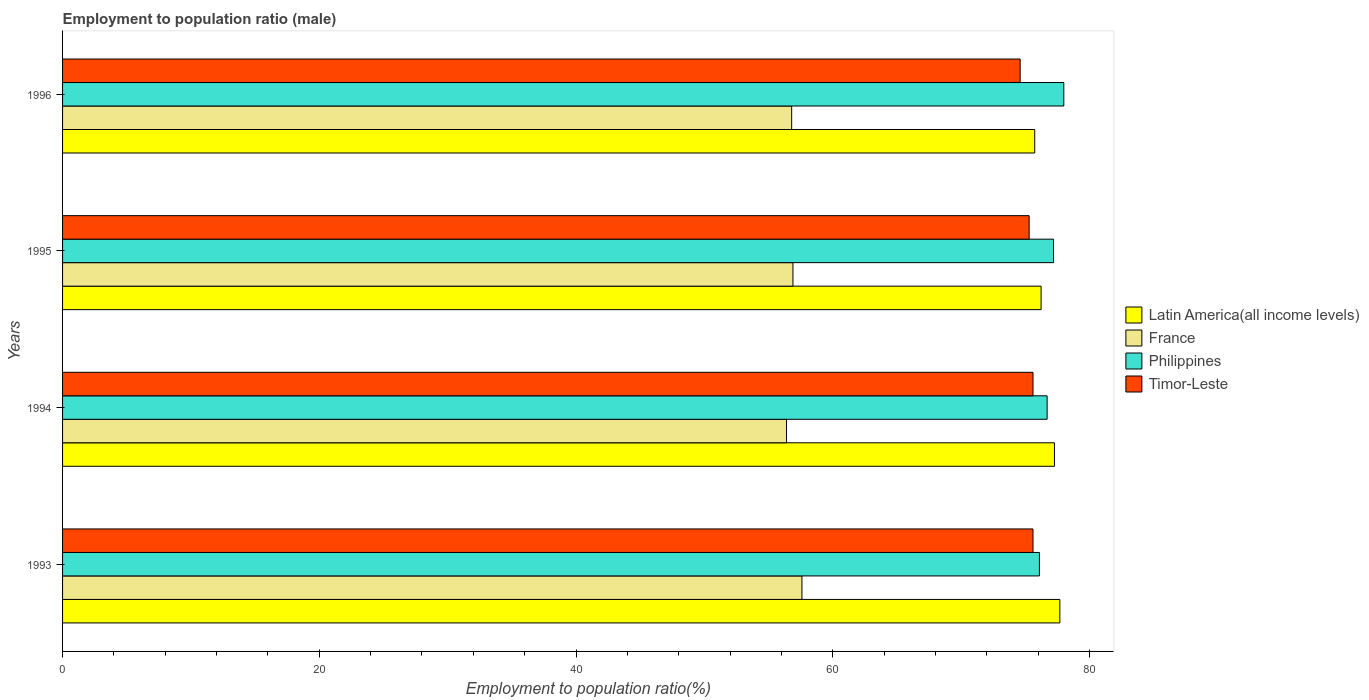How many different coloured bars are there?
Ensure brevity in your answer.  4. How many bars are there on the 3rd tick from the top?
Give a very brief answer. 4. How many bars are there on the 4th tick from the bottom?
Your answer should be compact. 4. In how many cases, is the number of bars for a given year not equal to the number of legend labels?
Provide a succinct answer. 0. What is the employment to population ratio in Timor-Leste in 1993?
Ensure brevity in your answer.  75.6. Across all years, what is the maximum employment to population ratio in Latin America(all income levels)?
Your answer should be compact. 77.69. Across all years, what is the minimum employment to population ratio in Timor-Leste?
Offer a terse response. 74.6. In which year was the employment to population ratio in France maximum?
Your answer should be very brief. 1993. In which year was the employment to population ratio in Philippines minimum?
Offer a very short reply. 1993. What is the total employment to population ratio in Philippines in the graph?
Your answer should be very brief. 308. What is the difference between the employment to population ratio in Philippines in 1995 and that in 1996?
Keep it short and to the point. -0.8. What is the difference between the employment to population ratio in France in 1993 and the employment to population ratio in Latin America(all income levels) in 1996?
Give a very brief answer. -18.13. What is the average employment to population ratio in Philippines per year?
Offer a terse response. 77. In the year 1996, what is the difference between the employment to population ratio in Timor-Leste and employment to population ratio in Latin America(all income levels)?
Offer a very short reply. -1.13. What is the ratio of the employment to population ratio in France in 1995 to that in 1996?
Give a very brief answer. 1. Is the difference between the employment to population ratio in Timor-Leste in 1994 and 1996 greater than the difference between the employment to population ratio in Latin America(all income levels) in 1994 and 1996?
Make the answer very short. No. What is the difference between the highest and the second highest employment to population ratio in Philippines?
Ensure brevity in your answer.  0.8. What is the difference between the highest and the lowest employment to population ratio in France?
Offer a terse response. 1.2. Is it the case that in every year, the sum of the employment to population ratio in France and employment to population ratio in Latin America(all income levels) is greater than the sum of employment to population ratio in Philippines and employment to population ratio in Timor-Leste?
Make the answer very short. No. What does the 3rd bar from the top in 1995 represents?
Your response must be concise. France. What does the 1st bar from the bottom in 1994 represents?
Offer a terse response. Latin America(all income levels). Is it the case that in every year, the sum of the employment to population ratio in France and employment to population ratio in Latin America(all income levels) is greater than the employment to population ratio in Philippines?
Your answer should be compact. Yes. How many bars are there?
Your response must be concise. 16. Are all the bars in the graph horizontal?
Your answer should be compact. Yes. How many years are there in the graph?
Ensure brevity in your answer.  4. Are the values on the major ticks of X-axis written in scientific E-notation?
Offer a very short reply. No. Where does the legend appear in the graph?
Your answer should be very brief. Center right. What is the title of the graph?
Offer a very short reply. Employment to population ratio (male). What is the label or title of the X-axis?
Offer a very short reply. Employment to population ratio(%). What is the Employment to population ratio(%) of Latin America(all income levels) in 1993?
Offer a terse response. 77.69. What is the Employment to population ratio(%) of France in 1993?
Keep it short and to the point. 57.6. What is the Employment to population ratio(%) in Philippines in 1993?
Keep it short and to the point. 76.1. What is the Employment to population ratio(%) of Timor-Leste in 1993?
Provide a short and direct response. 75.6. What is the Employment to population ratio(%) of Latin America(all income levels) in 1994?
Make the answer very short. 77.27. What is the Employment to population ratio(%) in France in 1994?
Your answer should be very brief. 56.4. What is the Employment to population ratio(%) of Philippines in 1994?
Keep it short and to the point. 76.7. What is the Employment to population ratio(%) in Timor-Leste in 1994?
Provide a short and direct response. 75.6. What is the Employment to population ratio(%) of Latin America(all income levels) in 1995?
Give a very brief answer. 76.23. What is the Employment to population ratio(%) in France in 1995?
Offer a terse response. 56.9. What is the Employment to population ratio(%) in Philippines in 1995?
Offer a terse response. 77.2. What is the Employment to population ratio(%) in Timor-Leste in 1995?
Offer a terse response. 75.3. What is the Employment to population ratio(%) of Latin America(all income levels) in 1996?
Ensure brevity in your answer.  75.73. What is the Employment to population ratio(%) in France in 1996?
Offer a terse response. 56.8. What is the Employment to population ratio(%) in Philippines in 1996?
Provide a succinct answer. 78. What is the Employment to population ratio(%) in Timor-Leste in 1996?
Make the answer very short. 74.6. Across all years, what is the maximum Employment to population ratio(%) in Latin America(all income levels)?
Offer a very short reply. 77.69. Across all years, what is the maximum Employment to population ratio(%) in France?
Ensure brevity in your answer.  57.6. Across all years, what is the maximum Employment to population ratio(%) of Philippines?
Your answer should be compact. 78. Across all years, what is the maximum Employment to population ratio(%) of Timor-Leste?
Ensure brevity in your answer.  75.6. Across all years, what is the minimum Employment to population ratio(%) in Latin America(all income levels)?
Ensure brevity in your answer.  75.73. Across all years, what is the minimum Employment to population ratio(%) of France?
Provide a short and direct response. 56.4. Across all years, what is the minimum Employment to population ratio(%) in Philippines?
Offer a very short reply. 76.1. Across all years, what is the minimum Employment to population ratio(%) of Timor-Leste?
Ensure brevity in your answer.  74.6. What is the total Employment to population ratio(%) of Latin America(all income levels) in the graph?
Make the answer very short. 306.93. What is the total Employment to population ratio(%) in France in the graph?
Offer a very short reply. 227.7. What is the total Employment to population ratio(%) in Philippines in the graph?
Provide a short and direct response. 308. What is the total Employment to population ratio(%) in Timor-Leste in the graph?
Your response must be concise. 301.1. What is the difference between the Employment to population ratio(%) of Latin America(all income levels) in 1993 and that in 1994?
Give a very brief answer. 0.42. What is the difference between the Employment to population ratio(%) in Philippines in 1993 and that in 1994?
Your answer should be compact. -0.6. What is the difference between the Employment to population ratio(%) of Latin America(all income levels) in 1993 and that in 1995?
Ensure brevity in your answer.  1.46. What is the difference between the Employment to population ratio(%) in France in 1993 and that in 1995?
Ensure brevity in your answer.  0.7. What is the difference between the Employment to population ratio(%) in Timor-Leste in 1993 and that in 1995?
Keep it short and to the point. 0.3. What is the difference between the Employment to population ratio(%) in Latin America(all income levels) in 1993 and that in 1996?
Ensure brevity in your answer.  1.96. What is the difference between the Employment to population ratio(%) in Latin America(all income levels) in 1994 and that in 1995?
Give a very brief answer. 1.04. What is the difference between the Employment to population ratio(%) in France in 1994 and that in 1995?
Your answer should be compact. -0.5. What is the difference between the Employment to population ratio(%) in Philippines in 1994 and that in 1995?
Make the answer very short. -0.5. What is the difference between the Employment to population ratio(%) in Timor-Leste in 1994 and that in 1995?
Keep it short and to the point. 0.3. What is the difference between the Employment to population ratio(%) in Latin America(all income levels) in 1994 and that in 1996?
Offer a very short reply. 1.54. What is the difference between the Employment to population ratio(%) in Timor-Leste in 1994 and that in 1996?
Your answer should be compact. 1. What is the difference between the Employment to population ratio(%) in Latin America(all income levels) in 1995 and that in 1996?
Provide a succinct answer. 0.49. What is the difference between the Employment to population ratio(%) of France in 1995 and that in 1996?
Your answer should be very brief. 0.1. What is the difference between the Employment to population ratio(%) in Philippines in 1995 and that in 1996?
Offer a terse response. -0.8. What is the difference between the Employment to population ratio(%) in Timor-Leste in 1995 and that in 1996?
Provide a short and direct response. 0.7. What is the difference between the Employment to population ratio(%) in Latin America(all income levels) in 1993 and the Employment to population ratio(%) in France in 1994?
Your response must be concise. 21.29. What is the difference between the Employment to population ratio(%) in Latin America(all income levels) in 1993 and the Employment to population ratio(%) in Philippines in 1994?
Provide a succinct answer. 0.99. What is the difference between the Employment to population ratio(%) of Latin America(all income levels) in 1993 and the Employment to population ratio(%) of Timor-Leste in 1994?
Ensure brevity in your answer.  2.09. What is the difference between the Employment to population ratio(%) of France in 1993 and the Employment to population ratio(%) of Philippines in 1994?
Your answer should be compact. -19.1. What is the difference between the Employment to population ratio(%) of Latin America(all income levels) in 1993 and the Employment to population ratio(%) of France in 1995?
Keep it short and to the point. 20.79. What is the difference between the Employment to population ratio(%) of Latin America(all income levels) in 1993 and the Employment to population ratio(%) of Philippines in 1995?
Your answer should be very brief. 0.49. What is the difference between the Employment to population ratio(%) of Latin America(all income levels) in 1993 and the Employment to population ratio(%) of Timor-Leste in 1995?
Your answer should be very brief. 2.39. What is the difference between the Employment to population ratio(%) of France in 1993 and the Employment to population ratio(%) of Philippines in 1995?
Ensure brevity in your answer.  -19.6. What is the difference between the Employment to population ratio(%) of France in 1993 and the Employment to population ratio(%) of Timor-Leste in 1995?
Give a very brief answer. -17.7. What is the difference between the Employment to population ratio(%) in Philippines in 1993 and the Employment to population ratio(%) in Timor-Leste in 1995?
Provide a short and direct response. 0.8. What is the difference between the Employment to population ratio(%) of Latin America(all income levels) in 1993 and the Employment to population ratio(%) of France in 1996?
Your answer should be very brief. 20.89. What is the difference between the Employment to population ratio(%) in Latin America(all income levels) in 1993 and the Employment to population ratio(%) in Philippines in 1996?
Provide a succinct answer. -0.31. What is the difference between the Employment to population ratio(%) in Latin America(all income levels) in 1993 and the Employment to population ratio(%) in Timor-Leste in 1996?
Provide a short and direct response. 3.09. What is the difference between the Employment to population ratio(%) in France in 1993 and the Employment to population ratio(%) in Philippines in 1996?
Ensure brevity in your answer.  -20.4. What is the difference between the Employment to population ratio(%) of Philippines in 1993 and the Employment to population ratio(%) of Timor-Leste in 1996?
Provide a succinct answer. 1.5. What is the difference between the Employment to population ratio(%) in Latin America(all income levels) in 1994 and the Employment to population ratio(%) in France in 1995?
Make the answer very short. 20.37. What is the difference between the Employment to population ratio(%) of Latin America(all income levels) in 1994 and the Employment to population ratio(%) of Philippines in 1995?
Provide a short and direct response. 0.07. What is the difference between the Employment to population ratio(%) in Latin America(all income levels) in 1994 and the Employment to population ratio(%) in Timor-Leste in 1995?
Ensure brevity in your answer.  1.97. What is the difference between the Employment to population ratio(%) of France in 1994 and the Employment to population ratio(%) of Philippines in 1995?
Your answer should be compact. -20.8. What is the difference between the Employment to population ratio(%) in France in 1994 and the Employment to population ratio(%) in Timor-Leste in 1995?
Offer a very short reply. -18.9. What is the difference between the Employment to population ratio(%) of Latin America(all income levels) in 1994 and the Employment to population ratio(%) of France in 1996?
Provide a succinct answer. 20.47. What is the difference between the Employment to population ratio(%) in Latin America(all income levels) in 1994 and the Employment to population ratio(%) in Philippines in 1996?
Provide a short and direct response. -0.73. What is the difference between the Employment to population ratio(%) of Latin America(all income levels) in 1994 and the Employment to population ratio(%) of Timor-Leste in 1996?
Your answer should be compact. 2.67. What is the difference between the Employment to population ratio(%) of France in 1994 and the Employment to population ratio(%) of Philippines in 1996?
Keep it short and to the point. -21.6. What is the difference between the Employment to population ratio(%) of France in 1994 and the Employment to population ratio(%) of Timor-Leste in 1996?
Ensure brevity in your answer.  -18.2. What is the difference between the Employment to population ratio(%) in Philippines in 1994 and the Employment to population ratio(%) in Timor-Leste in 1996?
Provide a succinct answer. 2.1. What is the difference between the Employment to population ratio(%) in Latin America(all income levels) in 1995 and the Employment to population ratio(%) in France in 1996?
Provide a short and direct response. 19.43. What is the difference between the Employment to population ratio(%) in Latin America(all income levels) in 1995 and the Employment to population ratio(%) in Philippines in 1996?
Your response must be concise. -1.77. What is the difference between the Employment to population ratio(%) of Latin America(all income levels) in 1995 and the Employment to population ratio(%) of Timor-Leste in 1996?
Your response must be concise. 1.63. What is the difference between the Employment to population ratio(%) in France in 1995 and the Employment to population ratio(%) in Philippines in 1996?
Make the answer very short. -21.1. What is the difference between the Employment to population ratio(%) of France in 1995 and the Employment to population ratio(%) of Timor-Leste in 1996?
Keep it short and to the point. -17.7. What is the average Employment to population ratio(%) in Latin America(all income levels) per year?
Your answer should be compact. 76.73. What is the average Employment to population ratio(%) in France per year?
Give a very brief answer. 56.92. What is the average Employment to population ratio(%) in Timor-Leste per year?
Your answer should be very brief. 75.28. In the year 1993, what is the difference between the Employment to population ratio(%) in Latin America(all income levels) and Employment to population ratio(%) in France?
Offer a terse response. 20.09. In the year 1993, what is the difference between the Employment to population ratio(%) in Latin America(all income levels) and Employment to population ratio(%) in Philippines?
Your answer should be compact. 1.59. In the year 1993, what is the difference between the Employment to population ratio(%) of Latin America(all income levels) and Employment to population ratio(%) of Timor-Leste?
Offer a terse response. 2.09. In the year 1993, what is the difference between the Employment to population ratio(%) in France and Employment to population ratio(%) in Philippines?
Ensure brevity in your answer.  -18.5. In the year 1994, what is the difference between the Employment to population ratio(%) of Latin America(all income levels) and Employment to population ratio(%) of France?
Your response must be concise. 20.87. In the year 1994, what is the difference between the Employment to population ratio(%) in Latin America(all income levels) and Employment to population ratio(%) in Philippines?
Offer a very short reply. 0.57. In the year 1994, what is the difference between the Employment to population ratio(%) of Latin America(all income levels) and Employment to population ratio(%) of Timor-Leste?
Make the answer very short. 1.67. In the year 1994, what is the difference between the Employment to population ratio(%) of France and Employment to population ratio(%) of Philippines?
Your response must be concise. -20.3. In the year 1994, what is the difference between the Employment to population ratio(%) in France and Employment to population ratio(%) in Timor-Leste?
Make the answer very short. -19.2. In the year 1995, what is the difference between the Employment to population ratio(%) in Latin America(all income levels) and Employment to population ratio(%) in France?
Provide a short and direct response. 19.33. In the year 1995, what is the difference between the Employment to population ratio(%) in Latin America(all income levels) and Employment to population ratio(%) in Philippines?
Give a very brief answer. -0.97. In the year 1995, what is the difference between the Employment to population ratio(%) of Latin America(all income levels) and Employment to population ratio(%) of Timor-Leste?
Provide a short and direct response. 0.93. In the year 1995, what is the difference between the Employment to population ratio(%) in France and Employment to population ratio(%) in Philippines?
Your response must be concise. -20.3. In the year 1995, what is the difference between the Employment to population ratio(%) in France and Employment to population ratio(%) in Timor-Leste?
Offer a terse response. -18.4. In the year 1996, what is the difference between the Employment to population ratio(%) in Latin America(all income levels) and Employment to population ratio(%) in France?
Keep it short and to the point. 18.93. In the year 1996, what is the difference between the Employment to population ratio(%) in Latin America(all income levels) and Employment to population ratio(%) in Philippines?
Make the answer very short. -2.27. In the year 1996, what is the difference between the Employment to population ratio(%) in Latin America(all income levels) and Employment to population ratio(%) in Timor-Leste?
Offer a very short reply. 1.13. In the year 1996, what is the difference between the Employment to population ratio(%) of France and Employment to population ratio(%) of Philippines?
Provide a short and direct response. -21.2. In the year 1996, what is the difference between the Employment to population ratio(%) of France and Employment to population ratio(%) of Timor-Leste?
Your response must be concise. -17.8. In the year 1996, what is the difference between the Employment to population ratio(%) in Philippines and Employment to population ratio(%) in Timor-Leste?
Keep it short and to the point. 3.4. What is the ratio of the Employment to population ratio(%) in Latin America(all income levels) in 1993 to that in 1994?
Your response must be concise. 1.01. What is the ratio of the Employment to population ratio(%) in France in 1993 to that in 1994?
Offer a very short reply. 1.02. What is the ratio of the Employment to population ratio(%) of Philippines in 1993 to that in 1994?
Make the answer very short. 0.99. What is the ratio of the Employment to population ratio(%) of Latin America(all income levels) in 1993 to that in 1995?
Provide a succinct answer. 1.02. What is the ratio of the Employment to population ratio(%) in France in 1993 to that in 1995?
Ensure brevity in your answer.  1.01. What is the ratio of the Employment to population ratio(%) of Philippines in 1993 to that in 1995?
Your answer should be compact. 0.99. What is the ratio of the Employment to population ratio(%) in Latin America(all income levels) in 1993 to that in 1996?
Provide a succinct answer. 1.03. What is the ratio of the Employment to population ratio(%) in France in 1993 to that in 1996?
Make the answer very short. 1.01. What is the ratio of the Employment to population ratio(%) of Philippines in 1993 to that in 1996?
Offer a terse response. 0.98. What is the ratio of the Employment to population ratio(%) of Timor-Leste in 1993 to that in 1996?
Your answer should be very brief. 1.01. What is the ratio of the Employment to population ratio(%) in Latin America(all income levels) in 1994 to that in 1995?
Offer a very short reply. 1.01. What is the ratio of the Employment to population ratio(%) of Philippines in 1994 to that in 1995?
Your response must be concise. 0.99. What is the ratio of the Employment to population ratio(%) in Latin America(all income levels) in 1994 to that in 1996?
Make the answer very short. 1.02. What is the ratio of the Employment to population ratio(%) in Philippines in 1994 to that in 1996?
Your answer should be compact. 0.98. What is the ratio of the Employment to population ratio(%) in Timor-Leste in 1994 to that in 1996?
Provide a short and direct response. 1.01. What is the ratio of the Employment to population ratio(%) of Timor-Leste in 1995 to that in 1996?
Keep it short and to the point. 1.01. What is the difference between the highest and the second highest Employment to population ratio(%) in Latin America(all income levels)?
Your answer should be very brief. 0.42. What is the difference between the highest and the lowest Employment to population ratio(%) in Latin America(all income levels)?
Offer a very short reply. 1.96. What is the difference between the highest and the lowest Employment to population ratio(%) of France?
Offer a very short reply. 1.2. What is the difference between the highest and the lowest Employment to population ratio(%) in Timor-Leste?
Give a very brief answer. 1. 